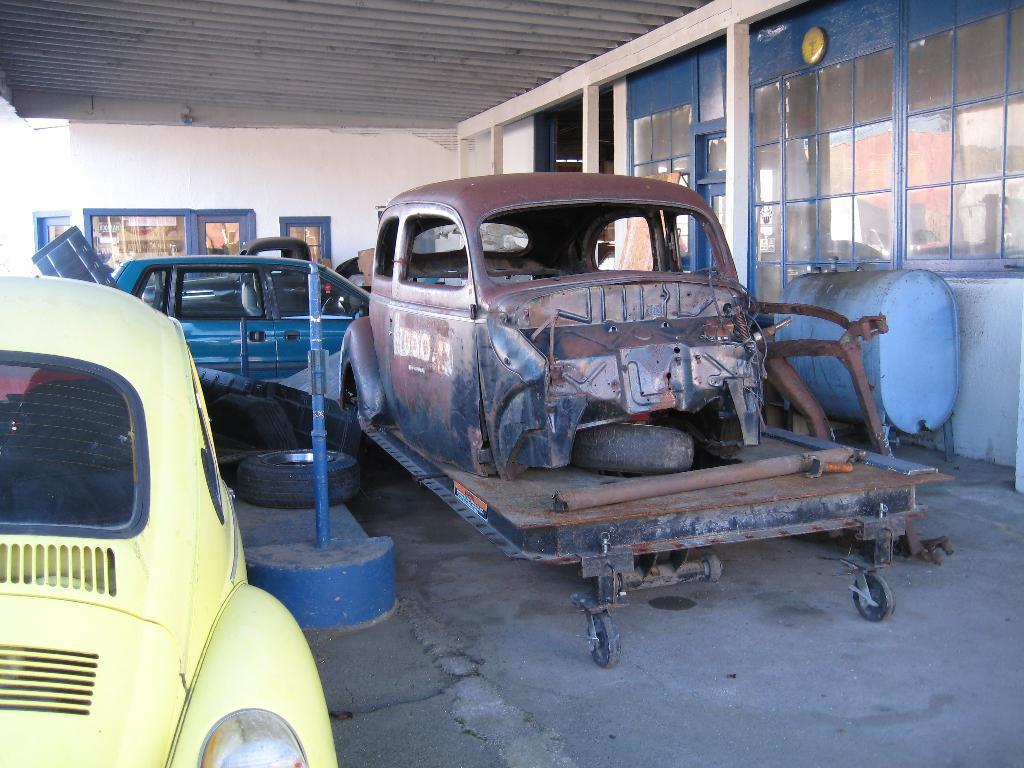How would you summarize this image in a sentence or two? We can see vehicles and tires. Background we can see wall and glasses. 